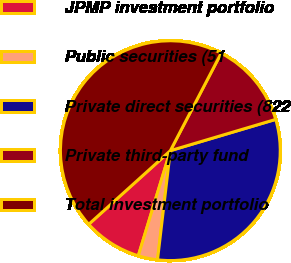Convert chart. <chart><loc_0><loc_0><loc_500><loc_500><pie_chart><fcel>JPMP investment portfolio<fcel>Public securities (51<fcel>Private direct securities (822<fcel>Private third-party fund<fcel>Total investment portfolio<nl><fcel>8.61%<fcel>2.85%<fcel>31.45%<fcel>12.76%<fcel>44.33%<nl></chart> 